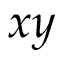Convert formula to latex. <formula><loc_0><loc_0><loc_500><loc_500>x y</formula> 